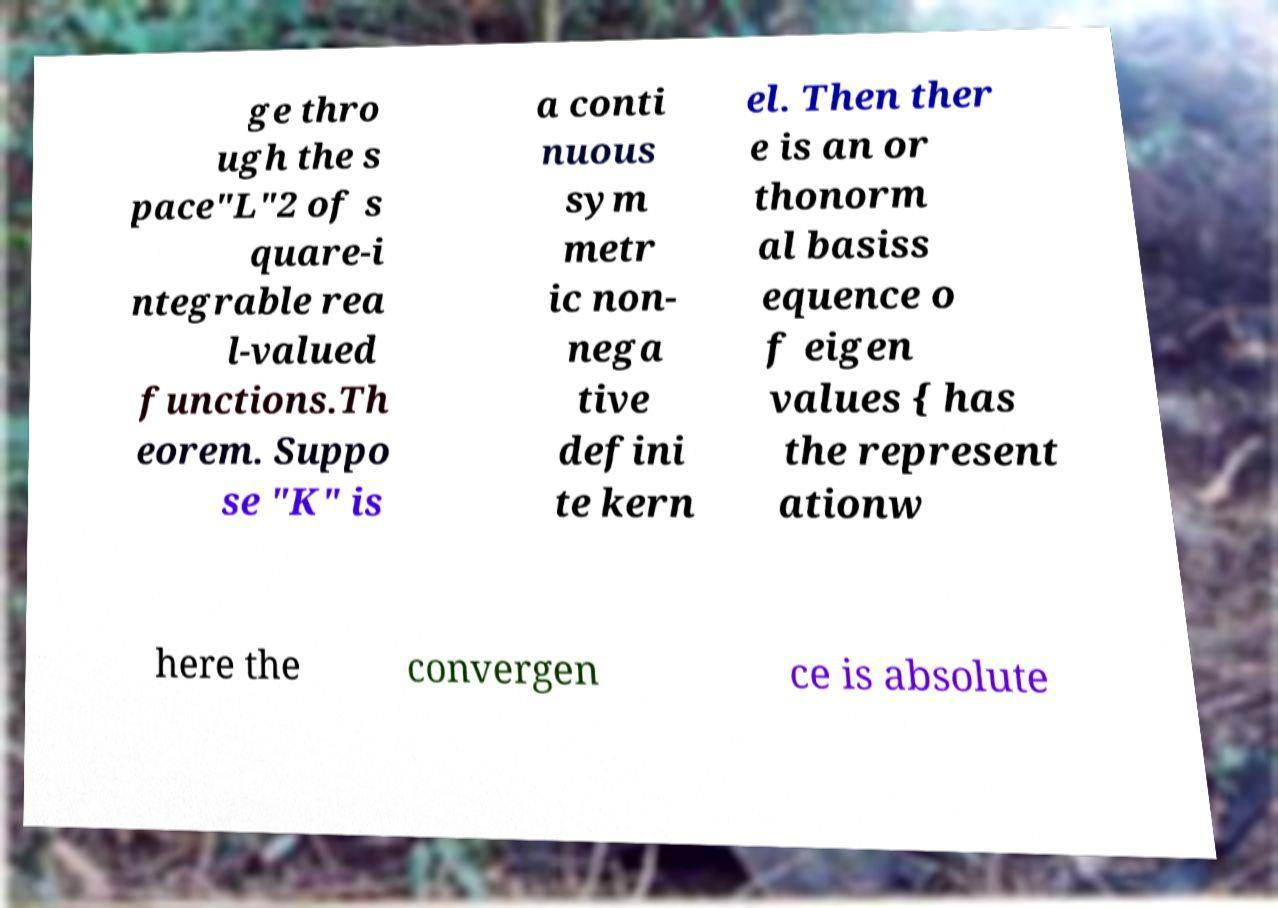Can you accurately transcribe the text from the provided image for me? ge thro ugh the s pace"L"2 of s quare-i ntegrable rea l-valued functions.Th eorem. Suppo se "K" is a conti nuous sym metr ic non- nega tive defini te kern el. Then ther e is an or thonorm al basiss equence o f eigen values { has the represent ationw here the convergen ce is absolute 